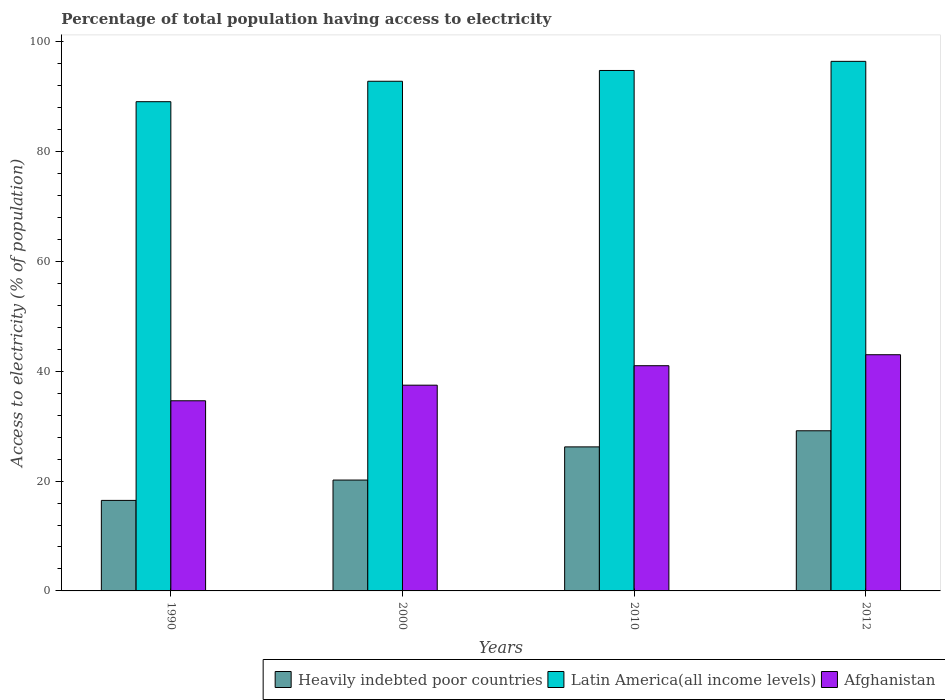How many groups of bars are there?
Offer a terse response. 4. How many bars are there on the 3rd tick from the right?
Your answer should be very brief. 3. In how many cases, is the number of bars for a given year not equal to the number of legend labels?
Ensure brevity in your answer.  0. What is the percentage of population that have access to electricity in Latin America(all income levels) in 2012?
Offer a very short reply. 96.41. Across all years, what is the maximum percentage of population that have access to electricity in Latin America(all income levels)?
Your answer should be very brief. 96.41. Across all years, what is the minimum percentage of population that have access to electricity in Afghanistan?
Offer a terse response. 34.62. In which year was the percentage of population that have access to electricity in Latin America(all income levels) maximum?
Make the answer very short. 2012. What is the total percentage of population that have access to electricity in Heavily indebted poor countries in the graph?
Your answer should be very brief. 92.04. What is the difference between the percentage of population that have access to electricity in Latin America(all income levels) in 2000 and that in 2012?
Provide a short and direct response. -3.62. What is the difference between the percentage of population that have access to electricity in Heavily indebted poor countries in 2010 and the percentage of population that have access to electricity in Afghanistan in 1990?
Give a very brief answer. -8.39. What is the average percentage of population that have access to electricity in Heavily indebted poor countries per year?
Your answer should be compact. 23.01. In the year 2010, what is the difference between the percentage of population that have access to electricity in Heavily indebted poor countries and percentage of population that have access to electricity in Afghanistan?
Keep it short and to the point. -14.78. What is the ratio of the percentage of population that have access to electricity in Latin America(all income levels) in 2010 to that in 2012?
Make the answer very short. 0.98. What is the difference between the highest and the lowest percentage of population that have access to electricity in Afghanistan?
Ensure brevity in your answer.  8.38. What does the 2nd bar from the left in 2012 represents?
Offer a terse response. Latin America(all income levels). What does the 1st bar from the right in 2000 represents?
Keep it short and to the point. Afghanistan. Is it the case that in every year, the sum of the percentage of population that have access to electricity in Afghanistan and percentage of population that have access to electricity in Latin America(all income levels) is greater than the percentage of population that have access to electricity in Heavily indebted poor countries?
Your answer should be very brief. Yes. Are the values on the major ticks of Y-axis written in scientific E-notation?
Ensure brevity in your answer.  No. Does the graph contain any zero values?
Make the answer very short. No. Does the graph contain grids?
Your response must be concise. No. How many legend labels are there?
Your response must be concise. 3. How are the legend labels stacked?
Give a very brief answer. Horizontal. What is the title of the graph?
Your answer should be very brief. Percentage of total population having access to electricity. Does "Small states" appear as one of the legend labels in the graph?
Your answer should be compact. No. What is the label or title of the X-axis?
Provide a succinct answer. Years. What is the label or title of the Y-axis?
Provide a succinct answer. Access to electricity (% of population). What is the Access to electricity (% of population) of Heavily indebted poor countries in 1990?
Keep it short and to the point. 16.48. What is the Access to electricity (% of population) in Latin America(all income levels) in 1990?
Provide a succinct answer. 89.06. What is the Access to electricity (% of population) of Afghanistan in 1990?
Give a very brief answer. 34.62. What is the Access to electricity (% of population) in Heavily indebted poor countries in 2000?
Your answer should be very brief. 20.18. What is the Access to electricity (% of population) in Latin America(all income levels) in 2000?
Your response must be concise. 92.78. What is the Access to electricity (% of population) in Afghanistan in 2000?
Keep it short and to the point. 37.46. What is the Access to electricity (% of population) of Heavily indebted poor countries in 2010?
Keep it short and to the point. 26.22. What is the Access to electricity (% of population) in Latin America(all income levels) in 2010?
Provide a succinct answer. 94.75. What is the Access to electricity (% of population) of Afghanistan in 2010?
Offer a terse response. 41. What is the Access to electricity (% of population) in Heavily indebted poor countries in 2012?
Make the answer very short. 29.15. What is the Access to electricity (% of population) of Latin America(all income levels) in 2012?
Offer a very short reply. 96.41. What is the Access to electricity (% of population) in Afghanistan in 2012?
Offer a terse response. 43. Across all years, what is the maximum Access to electricity (% of population) in Heavily indebted poor countries?
Provide a short and direct response. 29.15. Across all years, what is the maximum Access to electricity (% of population) in Latin America(all income levels)?
Keep it short and to the point. 96.41. Across all years, what is the maximum Access to electricity (% of population) in Afghanistan?
Provide a succinct answer. 43. Across all years, what is the minimum Access to electricity (% of population) of Heavily indebted poor countries?
Provide a succinct answer. 16.48. Across all years, what is the minimum Access to electricity (% of population) of Latin America(all income levels)?
Give a very brief answer. 89.06. Across all years, what is the minimum Access to electricity (% of population) in Afghanistan?
Your response must be concise. 34.62. What is the total Access to electricity (% of population) of Heavily indebted poor countries in the graph?
Offer a very short reply. 92.04. What is the total Access to electricity (% of population) of Latin America(all income levels) in the graph?
Ensure brevity in your answer.  373. What is the total Access to electricity (% of population) in Afghanistan in the graph?
Your answer should be very brief. 156.07. What is the difference between the Access to electricity (% of population) of Heavily indebted poor countries in 1990 and that in 2000?
Give a very brief answer. -3.7. What is the difference between the Access to electricity (% of population) in Latin America(all income levels) in 1990 and that in 2000?
Provide a short and direct response. -3.72. What is the difference between the Access to electricity (% of population) in Afghanistan in 1990 and that in 2000?
Provide a short and direct response. -2.84. What is the difference between the Access to electricity (% of population) of Heavily indebted poor countries in 1990 and that in 2010?
Offer a very short reply. -9.74. What is the difference between the Access to electricity (% of population) of Latin America(all income levels) in 1990 and that in 2010?
Provide a short and direct response. -5.68. What is the difference between the Access to electricity (% of population) in Afghanistan in 1990 and that in 2010?
Offer a terse response. -6.38. What is the difference between the Access to electricity (% of population) of Heavily indebted poor countries in 1990 and that in 2012?
Provide a short and direct response. -12.67. What is the difference between the Access to electricity (% of population) of Latin America(all income levels) in 1990 and that in 2012?
Ensure brevity in your answer.  -7.34. What is the difference between the Access to electricity (% of population) of Afghanistan in 1990 and that in 2012?
Provide a short and direct response. -8.38. What is the difference between the Access to electricity (% of population) of Heavily indebted poor countries in 2000 and that in 2010?
Provide a short and direct response. -6.04. What is the difference between the Access to electricity (% of population) of Latin America(all income levels) in 2000 and that in 2010?
Provide a short and direct response. -1.96. What is the difference between the Access to electricity (% of population) of Afghanistan in 2000 and that in 2010?
Your response must be concise. -3.54. What is the difference between the Access to electricity (% of population) in Heavily indebted poor countries in 2000 and that in 2012?
Your answer should be very brief. -8.97. What is the difference between the Access to electricity (% of population) of Latin America(all income levels) in 2000 and that in 2012?
Your answer should be very brief. -3.62. What is the difference between the Access to electricity (% of population) of Afghanistan in 2000 and that in 2012?
Your answer should be very brief. -5.54. What is the difference between the Access to electricity (% of population) of Heavily indebted poor countries in 2010 and that in 2012?
Provide a succinct answer. -2.93. What is the difference between the Access to electricity (% of population) in Latin America(all income levels) in 2010 and that in 2012?
Give a very brief answer. -1.66. What is the difference between the Access to electricity (% of population) in Afghanistan in 2010 and that in 2012?
Your answer should be very brief. -2. What is the difference between the Access to electricity (% of population) in Heavily indebted poor countries in 1990 and the Access to electricity (% of population) in Latin America(all income levels) in 2000?
Offer a very short reply. -76.3. What is the difference between the Access to electricity (% of population) of Heavily indebted poor countries in 1990 and the Access to electricity (% of population) of Afghanistan in 2000?
Your answer should be very brief. -20.98. What is the difference between the Access to electricity (% of population) in Latin America(all income levels) in 1990 and the Access to electricity (% of population) in Afghanistan in 2000?
Provide a short and direct response. 51.61. What is the difference between the Access to electricity (% of population) in Heavily indebted poor countries in 1990 and the Access to electricity (% of population) in Latin America(all income levels) in 2010?
Provide a succinct answer. -78.27. What is the difference between the Access to electricity (% of population) of Heavily indebted poor countries in 1990 and the Access to electricity (% of population) of Afghanistan in 2010?
Your answer should be very brief. -24.52. What is the difference between the Access to electricity (% of population) of Latin America(all income levels) in 1990 and the Access to electricity (% of population) of Afghanistan in 2010?
Make the answer very short. 48.06. What is the difference between the Access to electricity (% of population) in Heavily indebted poor countries in 1990 and the Access to electricity (% of population) in Latin America(all income levels) in 2012?
Offer a terse response. -79.93. What is the difference between the Access to electricity (% of population) in Heavily indebted poor countries in 1990 and the Access to electricity (% of population) in Afghanistan in 2012?
Offer a terse response. -26.52. What is the difference between the Access to electricity (% of population) in Latin America(all income levels) in 1990 and the Access to electricity (% of population) in Afghanistan in 2012?
Your answer should be compact. 46.06. What is the difference between the Access to electricity (% of population) in Heavily indebted poor countries in 2000 and the Access to electricity (% of population) in Latin America(all income levels) in 2010?
Your response must be concise. -74.56. What is the difference between the Access to electricity (% of population) in Heavily indebted poor countries in 2000 and the Access to electricity (% of population) in Afghanistan in 2010?
Keep it short and to the point. -20.82. What is the difference between the Access to electricity (% of population) in Latin America(all income levels) in 2000 and the Access to electricity (% of population) in Afghanistan in 2010?
Provide a short and direct response. 51.78. What is the difference between the Access to electricity (% of population) of Heavily indebted poor countries in 2000 and the Access to electricity (% of population) of Latin America(all income levels) in 2012?
Keep it short and to the point. -76.22. What is the difference between the Access to electricity (% of population) in Heavily indebted poor countries in 2000 and the Access to electricity (% of population) in Afghanistan in 2012?
Your answer should be compact. -22.82. What is the difference between the Access to electricity (% of population) of Latin America(all income levels) in 2000 and the Access to electricity (% of population) of Afghanistan in 2012?
Provide a succinct answer. 49.78. What is the difference between the Access to electricity (% of population) in Heavily indebted poor countries in 2010 and the Access to electricity (% of population) in Latin America(all income levels) in 2012?
Give a very brief answer. -70.19. What is the difference between the Access to electricity (% of population) in Heavily indebted poor countries in 2010 and the Access to electricity (% of population) in Afghanistan in 2012?
Offer a terse response. -16.78. What is the difference between the Access to electricity (% of population) in Latin America(all income levels) in 2010 and the Access to electricity (% of population) in Afghanistan in 2012?
Make the answer very short. 51.75. What is the average Access to electricity (% of population) of Heavily indebted poor countries per year?
Offer a terse response. 23.01. What is the average Access to electricity (% of population) in Latin America(all income levels) per year?
Provide a short and direct response. 93.25. What is the average Access to electricity (% of population) of Afghanistan per year?
Your answer should be very brief. 39.02. In the year 1990, what is the difference between the Access to electricity (% of population) of Heavily indebted poor countries and Access to electricity (% of population) of Latin America(all income levels)?
Offer a very short reply. -72.58. In the year 1990, what is the difference between the Access to electricity (% of population) in Heavily indebted poor countries and Access to electricity (% of population) in Afghanistan?
Your answer should be very brief. -18.14. In the year 1990, what is the difference between the Access to electricity (% of population) of Latin America(all income levels) and Access to electricity (% of population) of Afghanistan?
Your answer should be compact. 54.45. In the year 2000, what is the difference between the Access to electricity (% of population) in Heavily indebted poor countries and Access to electricity (% of population) in Latin America(all income levels)?
Your response must be concise. -72.6. In the year 2000, what is the difference between the Access to electricity (% of population) of Heavily indebted poor countries and Access to electricity (% of population) of Afghanistan?
Make the answer very short. -17.27. In the year 2000, what is the difference between the Access to electricity (% of population) in Latin America(all income levels) and Access to electricity (% of population) in Afghanistan?
Your answer should be compact. 55.33. In the year 2010, what is the difference between the Access to electricity (% of population) of Heavily indebted poor countries and Access to electricity (% of population) of Latin America(all income levels)?
Give a very brief answer. -68.52. In the year 2010, what is the difference between the Access to electricity (% of population) of Heavily indebted poor countries and Access to electricity (% of population) of Afghanistan?
Provide a succinct answer. -14.78. In the year 2010, what is the difference between the Access to electricity (% of population) of Latin America(all income levels) and Access to electricity (% of population) of Afghanistan?
Your response must be concise. 53.75. In the year 2012, what is the difference between the Access to electricity (% of population) of Heavily indebted poor countries and Access to electricity (% of population) of Latin America(all income levels)?
Offer a terse response. -67.25. In the year 2012, what is the difference between the Access to electricity (% of population) in Heavily indebted poor countries and Access to electricity (% of population) in Afghanistan?
Keep it short and to the point. -13.85. In the year 2012, what is the difference between the Access to electricity (% of population) in Latin America(all income levels) and Access to electricity (% of population) in Afghanistan?
Your answer should be compact. 53.41. What is the ratio of the Access to electricity (% of population) of Heavily indebted poor countries in 1990 to that in 2000?
Provide a short and direct response. 0.82. What is the ratio of the Access to electricity (% of population) in Latin America(all income levels) in 1990 to that in 2000?
Ensure brevity in your answer.  0.96. What is the ratio of the Access to electricity (% of population) in Afghanistan in 1990 to that in 2000?
Offer a very short reply. 0.92. What is the ratio of the Access to electricity (% of population) in Heavily indebted poor countries in 1990 to that in 2010?
Make the answer very short. 0.63. What is the ratio of the Access to electricity (% of population) in Afghanistan in 1990 to that in 2010?
Provide a short and direct response. 0.84. What is the ratio of the Access to electricity (% of population) in Heavily indebted poor countries in 1990 to that in 2012?
Your answer should be very brief. 0.57. What is the ratio of the Access to electricity (% of population) in Latin America(all income levels) in 1990 to that in 2012?
Your answer should be very brief. 0.92. What is the ratio of the Access to electricity (% of population) of Afghanistan in 1990 to that in 2012?
Give a very brief answer. 0.81. What is the ratio of the Access to electricity (% of population) of Heavily indebted poor countries in 2000 to that in 2010?
Provide a succinct answer. 0.77. What is the ratio of the Access to electricity (% of population) of Latin America(all income levels) in 2000 to that in 2010?
Ensure brevity in your answer.  0.98. What is the ratio of the Access to electricity (% of population) of Afghanistan in 2000 to that in 2010?
Provide a short and direct response. 0.91. What is the ratio of the Access to electricity (% of population) in Heavily indebted poor countries in 2000 to that in 2012?
Provide a short and direct response. 0.69. What is the ratio of the Access to electricity (% of population) in Latin America(all income levels) in 2000 to that in 2012?
Offer a terse response. 0.96. What is the ratio of the Access to electricity (% of population) in Afghanistan in 2000 to that in 2012?
Offer a terse response. 0.87. What is the ratio of the Access to electricity (% of population) of Heavily indebted poor countries in 2010 to that in 2012?
Provide a short and direct response. 0.9. What is the ratio of the Access to electricity (% of population) in Latin America(all income levels) in 2010 to that in 2012?
Offer a very short reply. 0.98. What is the ratio of the Access to electricity (% of population) of Afghanistan in 2010 to that in 2012?
Offer a terse response. 0.95. What is the difference between the highest and the second highest Access to electricity (% of population) in Heavily indebted poor countries?
Offer a very short reply. 2.93. What is the difference between the highest and the second highest Access to electricity (% of population) of Latin America(all income levels)?
Your answer should be compact. 1.66. What is the difference between the highest and the second highest Access to electricity (% of population) in Afghanistan?
Provide a short and direct response. 2. What is the difference between the highest and the lowest Access to electricity (% of population) of Heavily indebted poor countries?
Keep it short and to the point. 12.67. What is the difference between the highest and the lowest Access to electricity (% of population) of Latin America(all income levels)?
Give a very brief answer. 7.34. What is the difference between the highest and the lowest Access to electricity (% of population) in Afghanistan?
Provide a short and direct response. 8.38. 